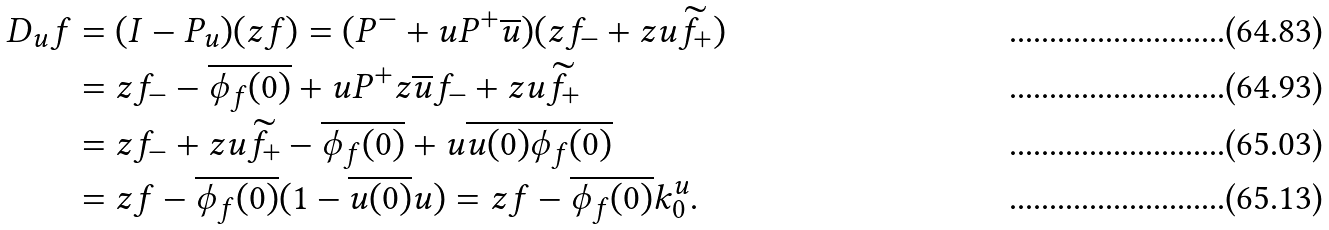<formula> <loc_0><loc_0><loc_500><loc_500>D _ { u } f & = ( I - P _ { u } ) ( z f ) = ( P ^ { - } + u P ^ { + } \overline { u } ) ( z f _ { - } + z u \widetilde { f _ { + } } ) \\ & = z f _ { - } - \overline { \phi _ { f } ( 0 ) } + u P ^ { + } z \overline { u } f _ { - } + z u \widetilde { f _ { + } } \\ & = z f _ { - } + z u \widetilde { f _ { + } } - \overline { \phi _ { f } ( 0 ) } + u \overline { u ( 0 ) } \overline { \phi _ { f } ( 0 ) } \\ & = z f - \overline { \phi _ { f } ( 0 ) } ( 1 - \overline { u ( 0 ) } u ) = z f - \overline { \phi _ { f } ( 0 ) } k _ { 0 } ^ { u } .</formula> 